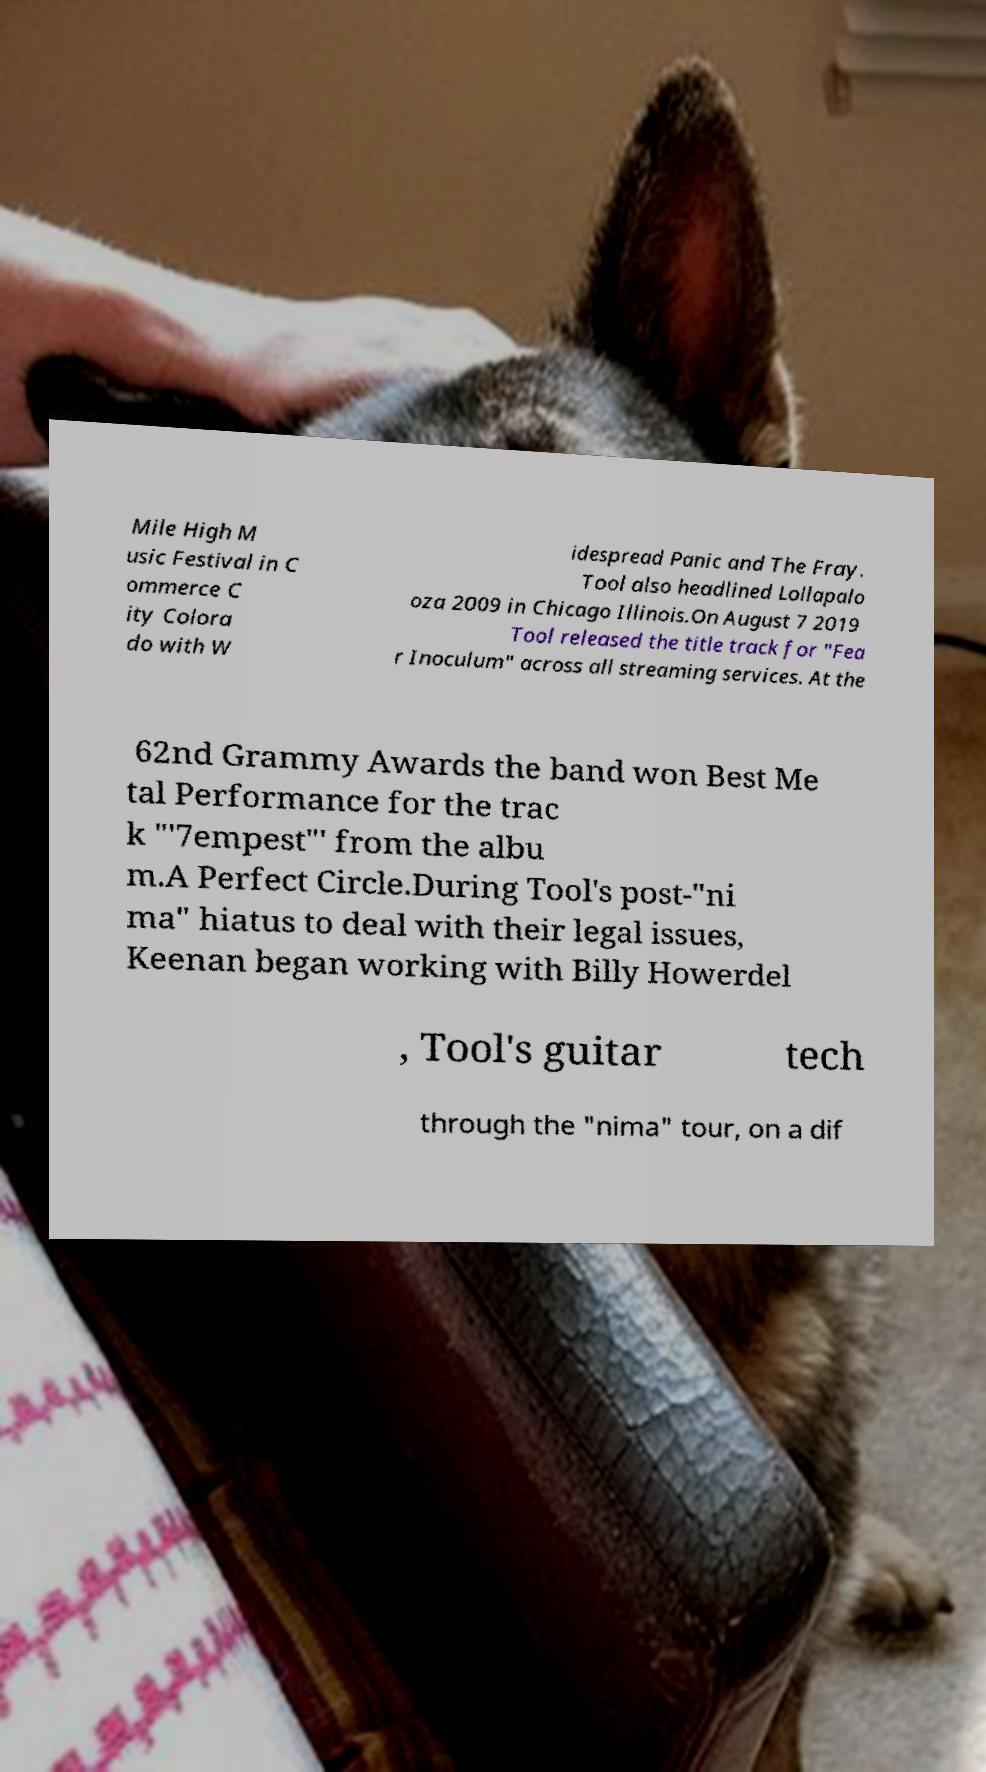There's text embedded in this image that I need extracted. Can you transcribe it verbatim? Mile High M usic Festival in C ommerce C ity Colora do with W idespread Panic and The Fray. Tool also headlined Lollapalo oza 2009 in Chicago Illinois.On August 7 2019 Tool released the title track for "Fea r Inoculum" across all streaming services. At the 62nd Grammy Awards the band won Best Me tal Performance for the trac k "'7empest"' from the albu m.A Perfect Circle.During Tool's post-"ni ma" hiatus to deal with their legal issues, Keenan began working with Billy Howerdel , Tool's guitar tech through the "nima" tour, on a dif 